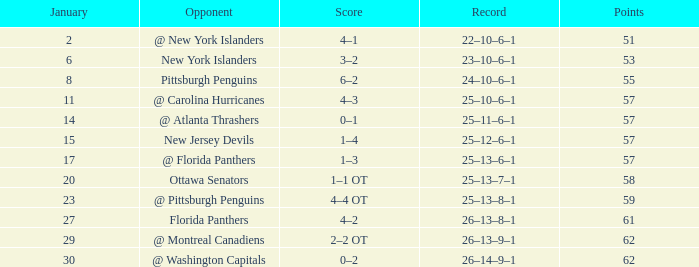What opponent has an average less than 62 and a january average less than 6 @ New York Islanders. 